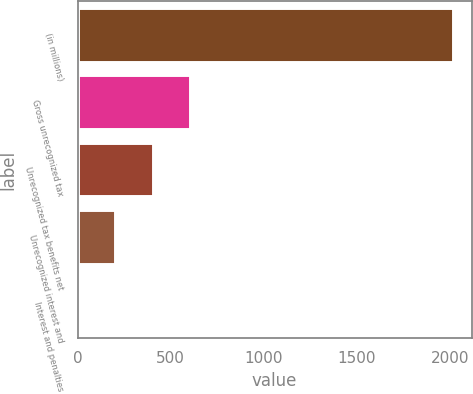Convert chart to OTSL. <chart><loc_0><loc_0><loc_500><loc_500><bar_chart><fcel>(in millions)<fcel>Gross unrecognized tax<fcel>Unrecognized tax benefits net<fcel>Unrecognized interest and<fcel>Interest and penalties<nl><fcel>2017<fcel>606.01<fcel>404.44<fcel>202.87<fcel>1.3<nl></chart> 